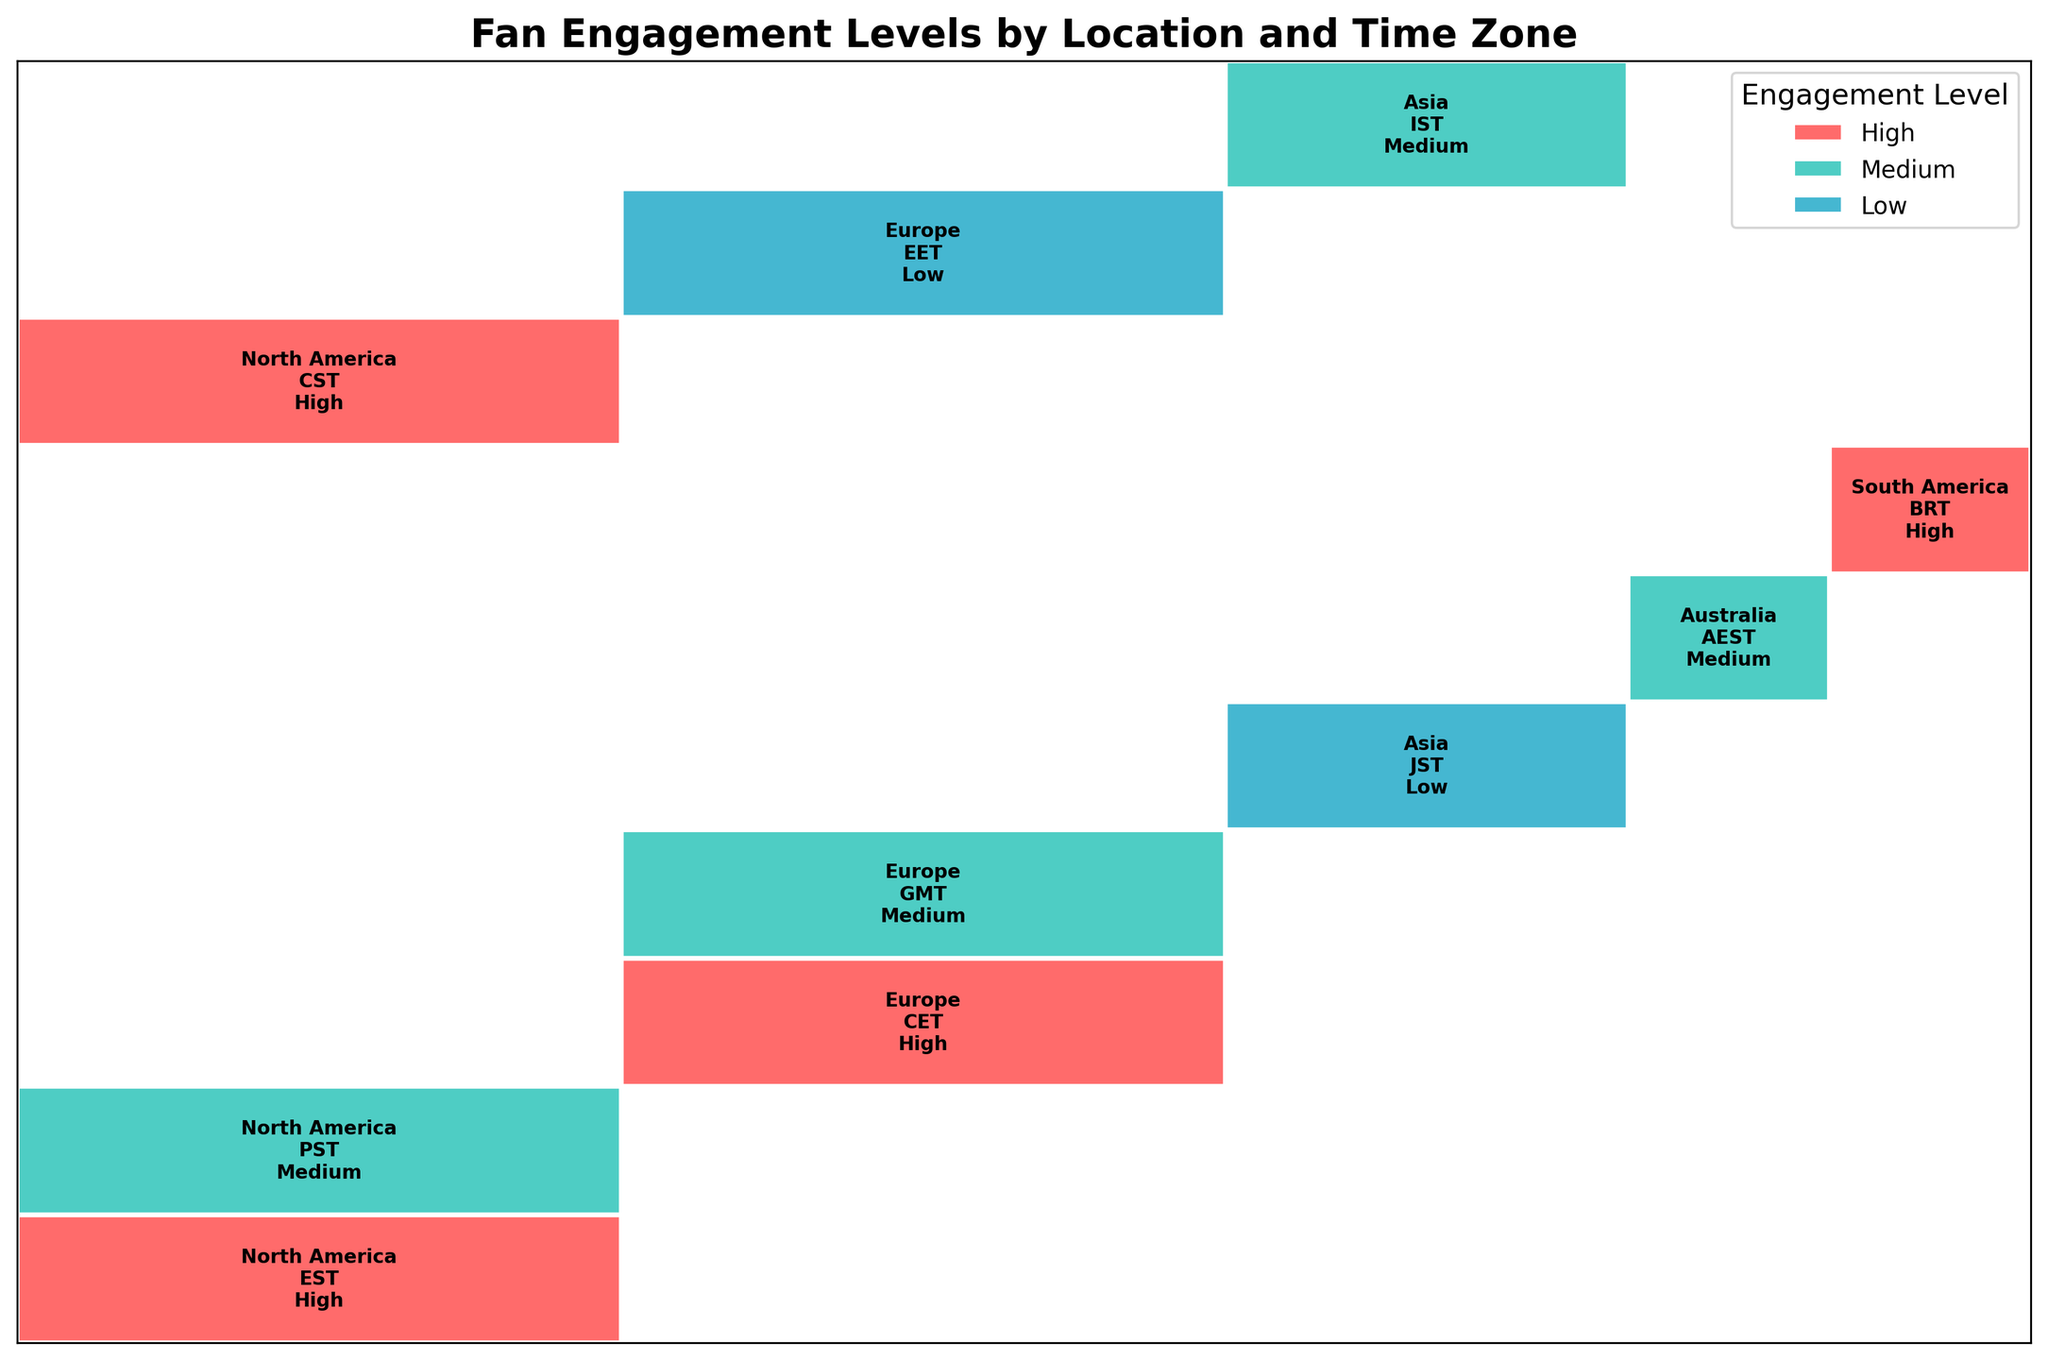what is the overall title of the figure? The title is written at the top of the figure and summarizes what the plot is about.
Answer: Fan Engagement Levels by Location and Time Zone which time zone has the highest engagement level from North America? We need to look for the time zone listed under North America with the "High" engagement level. The "High" section is colored in red.
Answer: EST what engagement level does Europe have in GMT? Find the section within Europe labeled with GMT, and identify the engagement level associated with it.
Answer: Medium How many time zones in Asia have medium engagement levels? Identify all the sections labeled "Asia" and count how many of them have "Medium" engagement levels, indicated by cyan color.
Answer: 1 which location has high engagement in more than one time zone? Look through each location to spot multiple sectors with "High" engagement levels, indicated with red color. Only one location matches this criterion.
Answer: North America What is the engagement level for Episode Reactions in South America? Find the rectangle labeled with South America and look for the section with the activity type "Episode Reactions." The associated engagement level is present there.
Answer: High compare the engagement levels of Cosplay Showcases in Europe and Merchandise Trading in Asia. Identify the time zones and see the engagement levels in the figure. Cosplay Showcases (Europe, GMT) has a medium level and Merchandise Trading (Asia, JST) has a low level.
Answer: Medium is higher than Low How many rectangles in the plot represent low engagement? Count the number of rectangles that are colored in blue, indicating "Low".
Answer: 2 which time zone in Europe has the lowest engagement level? Inspect the engagement levels listed under each time zone for Europe, and identify the one with the "Low" engagement.
Answer: EET compare the engagement levels of Virtual Watch Parties in North America to Character Analysis in Asia. Locate both activities and compare their associated engagement levels. Virtual Watch Parties (North America, CST) have high engagement whereas Character Analysis (Asia, IST) has medium.
Answer: High is higher than Medium 